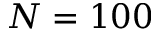<formula> <loc_0><loc_0><loc_500><loc_500>N = 1 0 0</formula> 